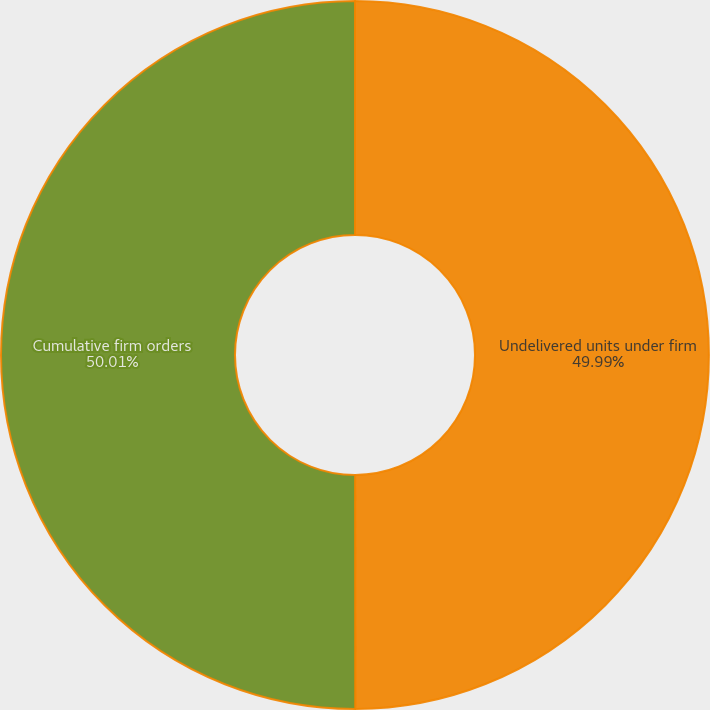Convert chart to OTSL. <chart><loc_0><loc_0><loc_500><loc_500><pie_chart><fcel>Undelivered units under firm<fcel>Cumulative firm orders<nl><fcel>49.99%<fcel>50.01%<nl></chart> 